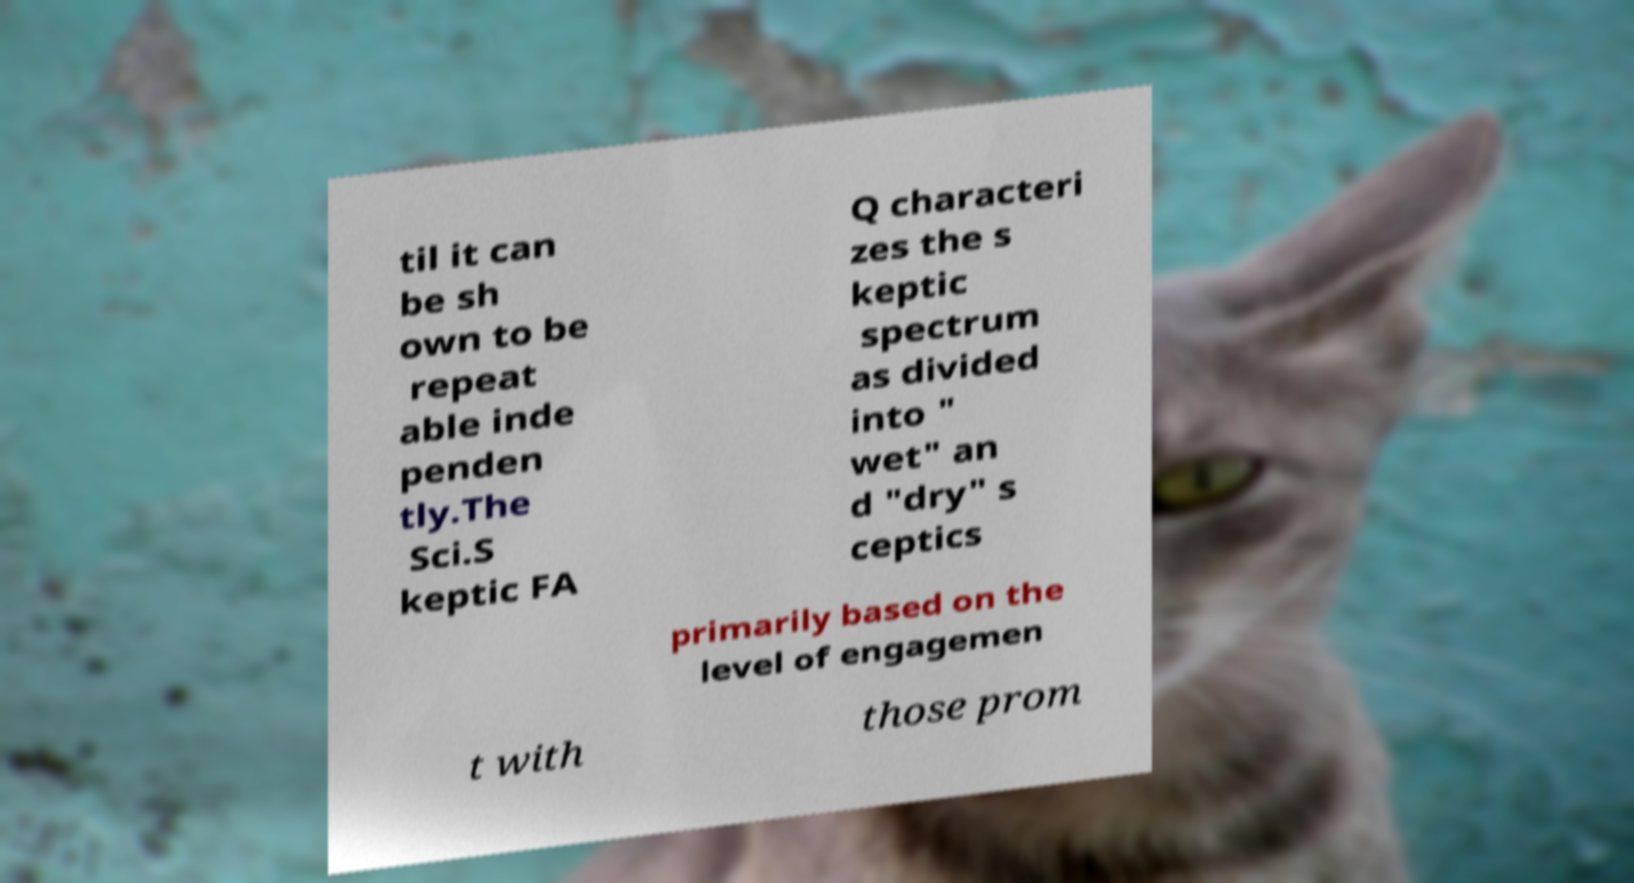Could you extract and type out the text from this image? til it can be sh own to be repeat able inde penden tly.The Sci.S keptic FA Q characteri zes the s keptic spectrum as divided into " wet" an d "dry" s ceptics primarily based on the level of engagemen t with those prom 